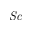<formula> <loc_0><loc_0><loc_500><loc_500>S c</formula> 